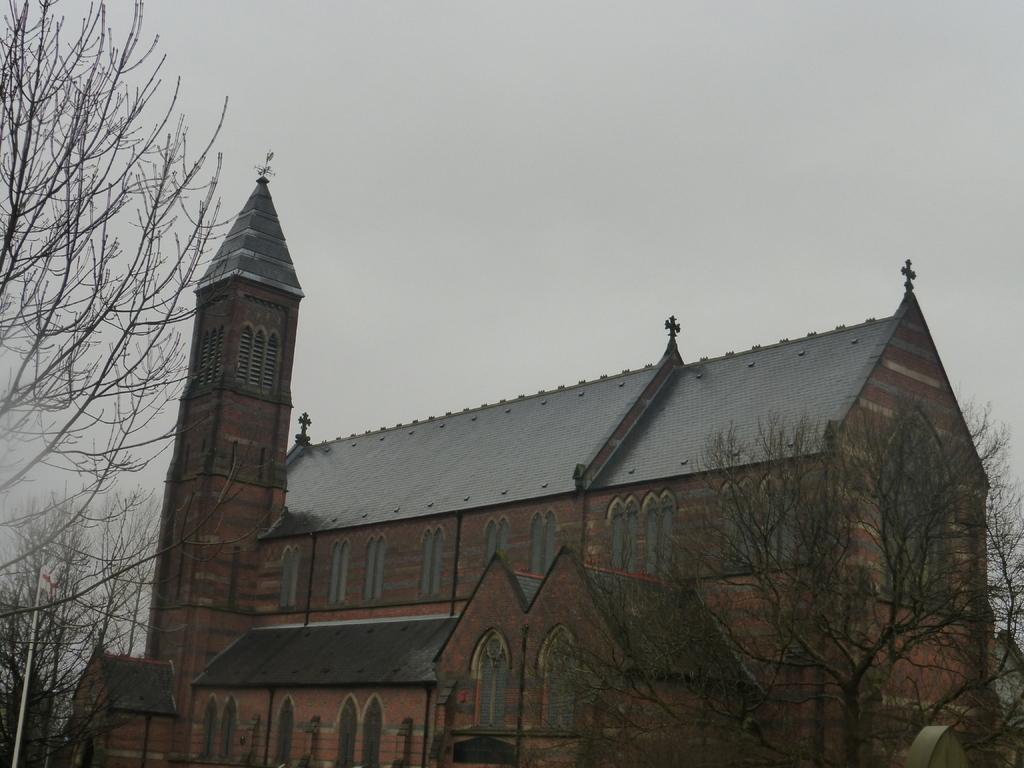What type of structure is present in the image? There is a building in the image. What other elements can be seen in the image besides the building? There are trees and the sky visible in the image. What is the condition of the sky in the image? The sky is cloudy in the image. What type of education can be seen taking place in the image? There is no indication of any educational activity taking place in the image. Can you tell me how the steam is being used in the image? There is no steam present in the image. 